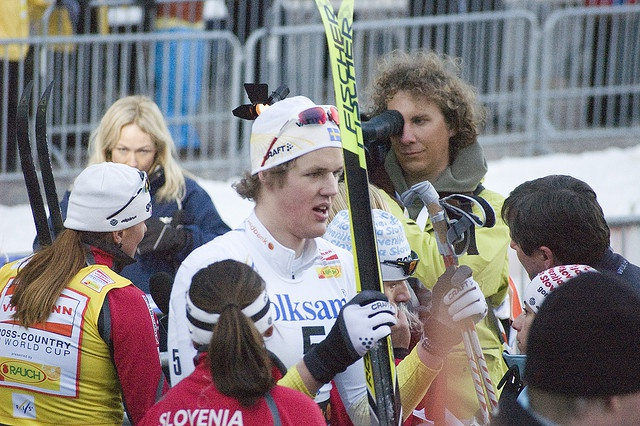Describe the objects in this image and their specific colors. I can see people in khaki, lavender, maroon, olive, and brown tones, people in khaki, lavender, darkgray, and gray tones, people in khaki, gray, tan, and darkgray tones, people in khaki, black, and gray tones, and people in khaki, black, brown, gray, and lavender tones in this image. 